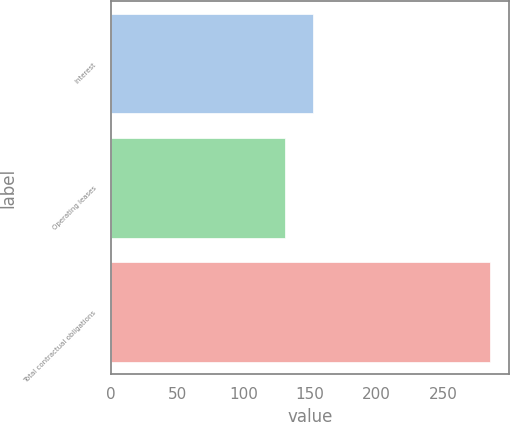Convert chart. <chart><loc_0><loc_0><loc_500><loc_500><bar_chart><fcel>Interest<fcel>Operating leases<fcel>Total contractual obligations<nl><fcel>152<fcel>131<fcel>285<nl></chart> 